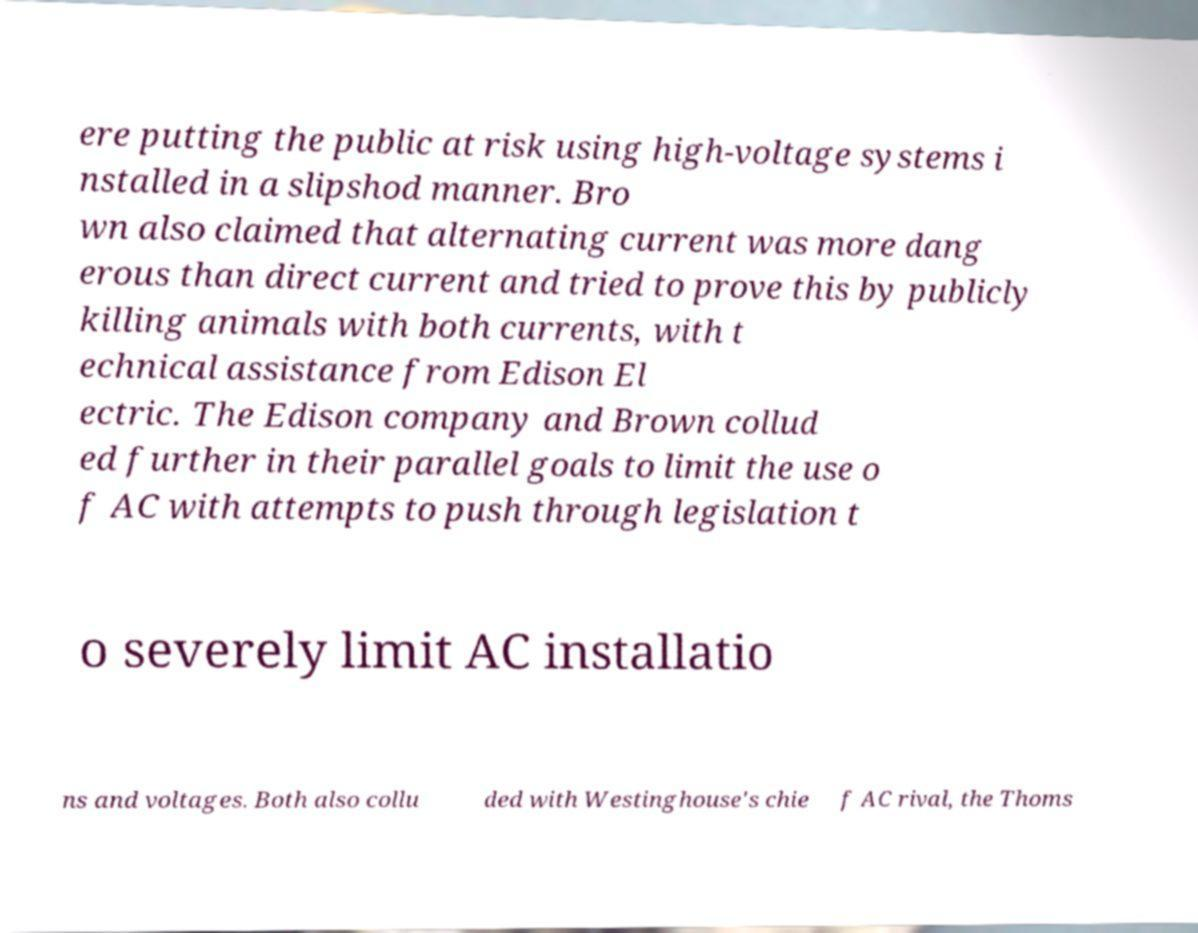I need the written content from this picture converted into text. Can you do that? ere putting the public at risk using high-voltage systems i nstalled in a slipshod manner. Bro wn also claimed that alternating current was more dang erous than direct current and tried to prove this by publicly killing animals with both currents, with t echnical assistance from Edison El ectric. The Edison company and Brown collud ed further in their parallel goals to limit the use o f AC with attempts to push through legislation t o severely limit AC installatio ns and voltages. Both also collu ded with Westinghouse's chie f AC rival, the Thoms 